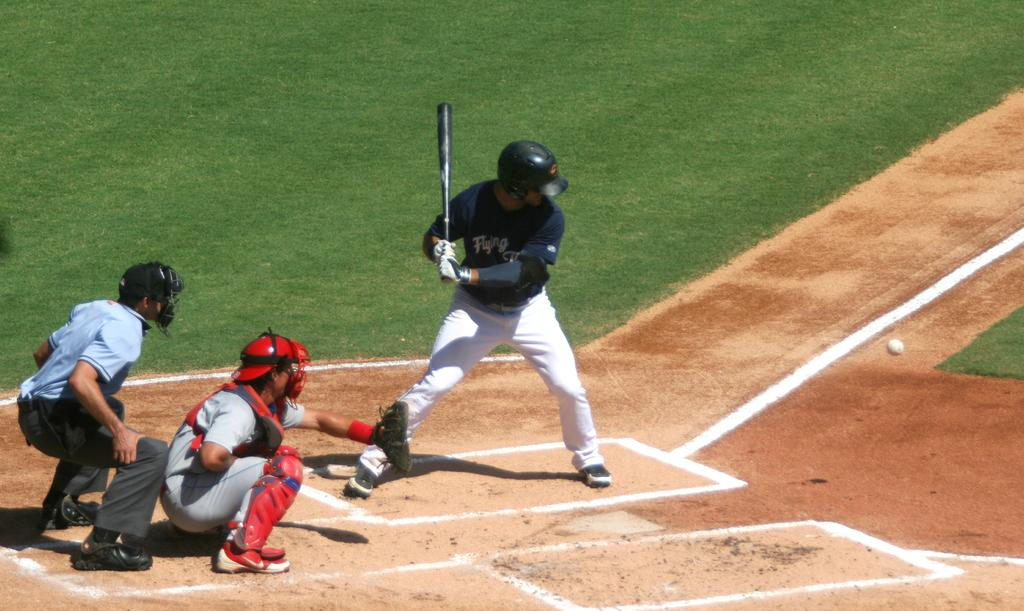Where was the image taken? The image was taken in a playground. How many people are in the image? There are three persons in the image. What is one person holding in the image? One person is holding a basketball bat. What is the person holding the basketball bat standing on? The person holding the basketball bat is standing on the ground. What else can be seen in the image besides the people? There is a ball visible in the image. What color is the person's toenail polish in the image? There is no mention of toenail polish or any focus on the person's toes in the image. 